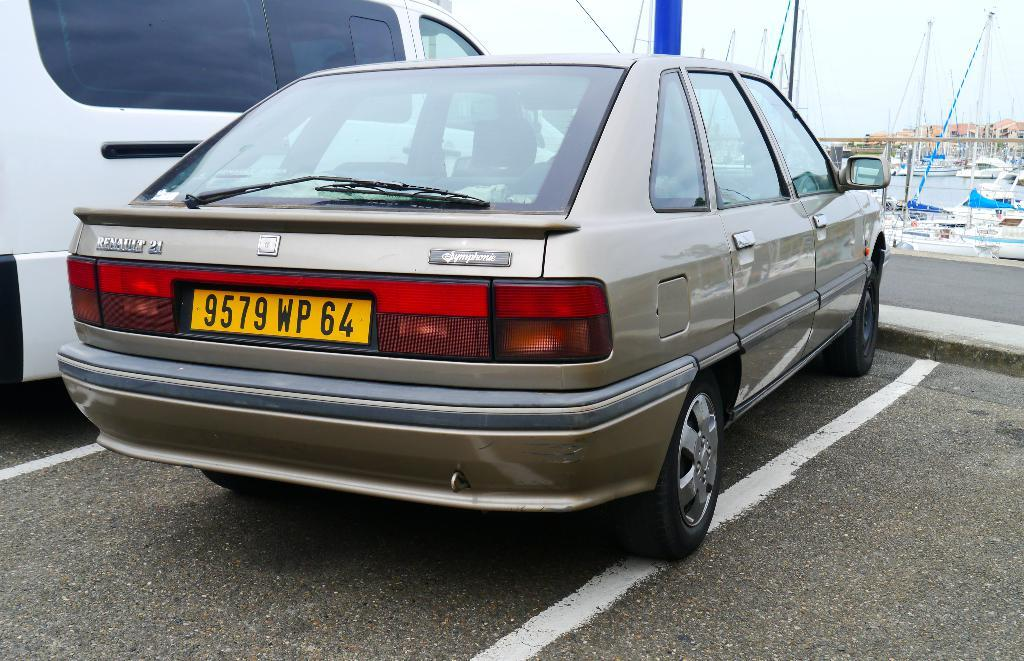What is the main subject in the center of the image? There is a car in the center of the image. What other vehicle can be seen in the image? There is a van at the top side of the image. What can be seen in the background of the image? Ships are visible in the background of the image. What is the ships' location in relation to the water? The ships are on water. How does the car's self-growth contribute to its performance in the image? The car does not exhibit self-growth in the image, as it is a static object. What type of fowl can be seen flying over the ships in the image? There are no fowl visible in the image; only ships are present on the water. 